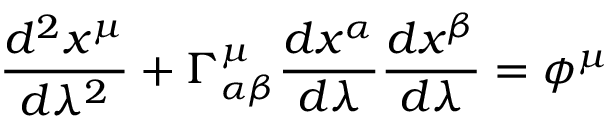Convert formula to latex. <formula><loc_0><loc_0><loc_500><loc_500>\frac { d ^ { 2 } x ^ { \mu } } { d \lambda ^ { 2 } } + \Gamma _ { \alpha \beta } ^ { \mu } \frac { d x ^ { \alpha } } { d \lambda } \frac { d x ^ { \beta } } { d \lambda } = \phi ^ { \mu }</formula> 